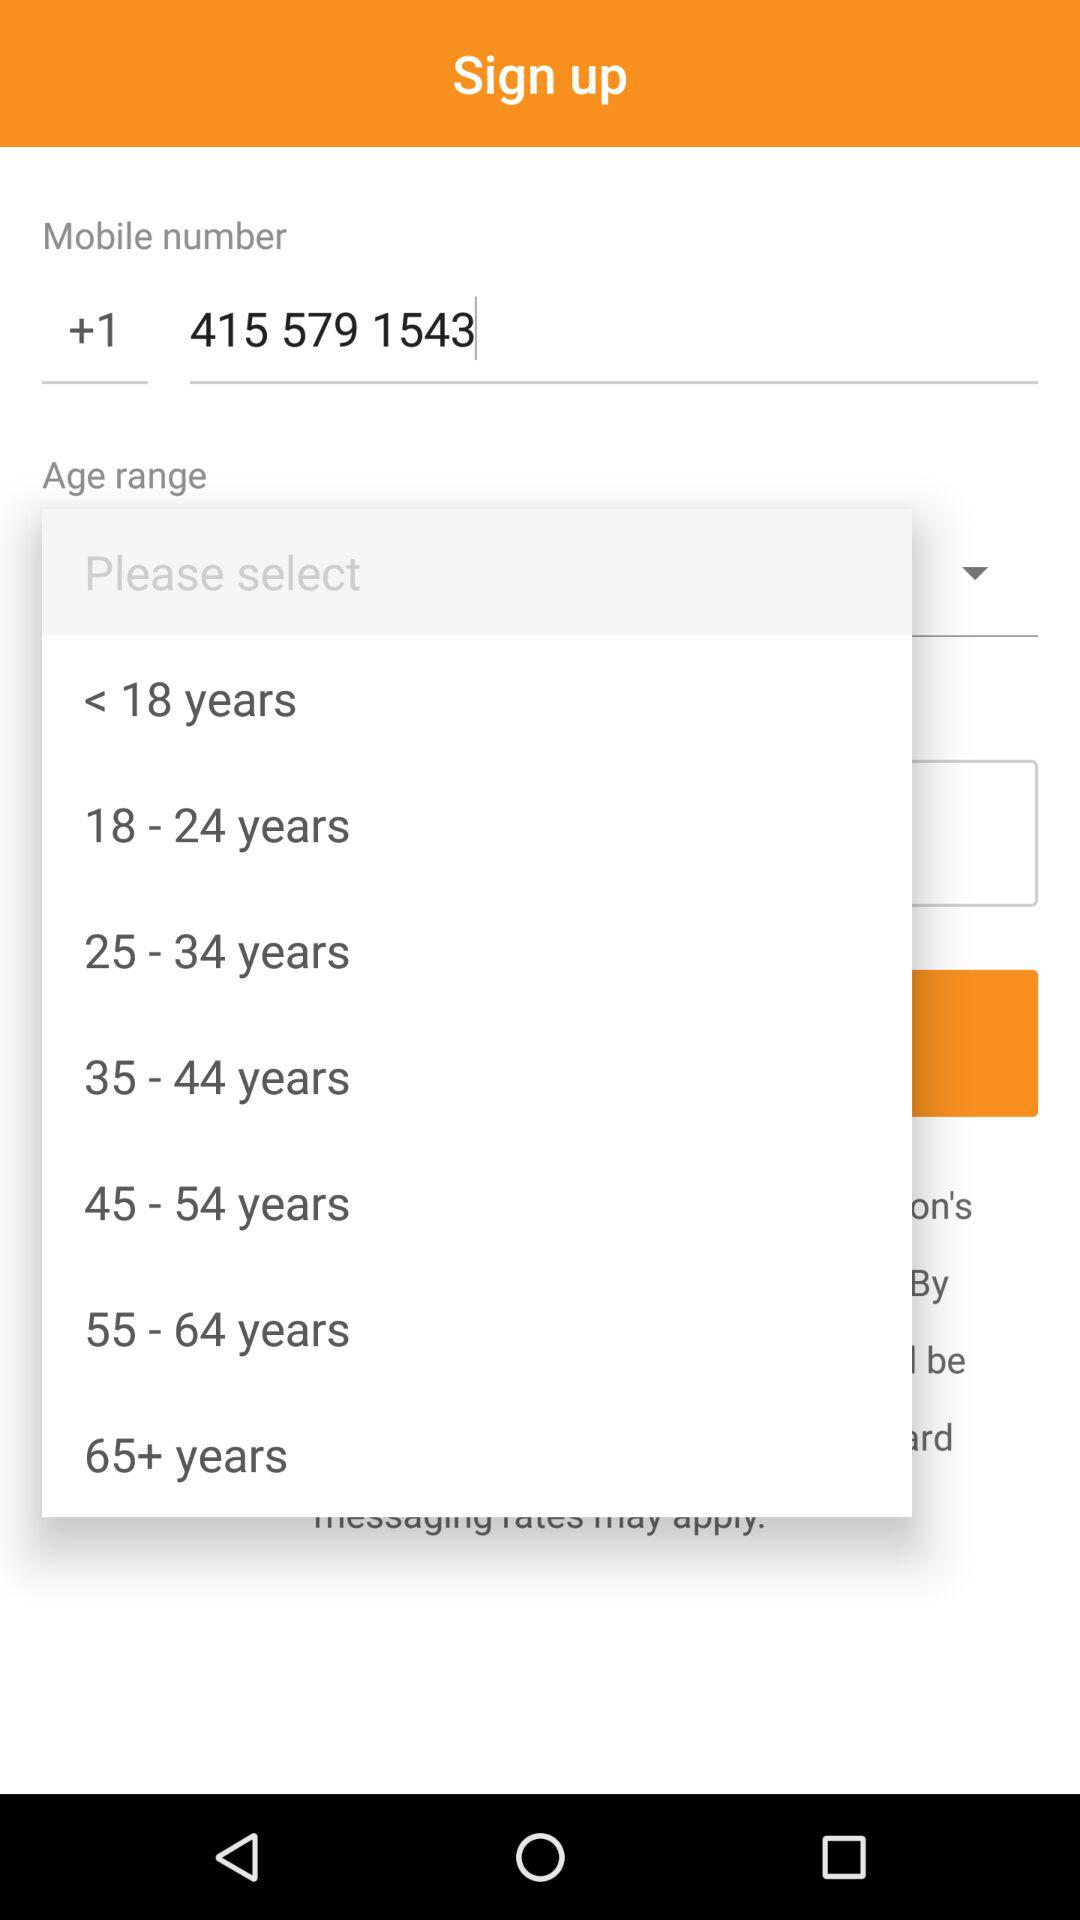How many age range options are there?
Answer the question using a single word or phrase. 7 